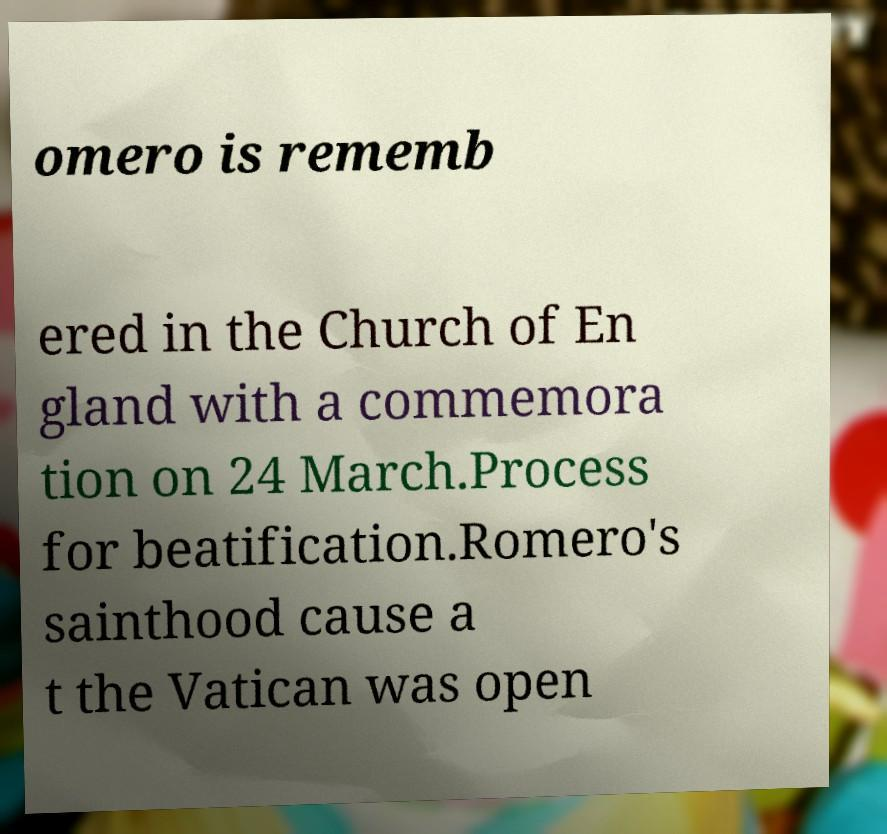Could you assist in decoding the text presented in this image and type it out clearly? omero is rememb ered in the Church of En gland with a commemora tion on 24 March.Process for beatification.Romero's sainthood cause a t the Vatican was open 